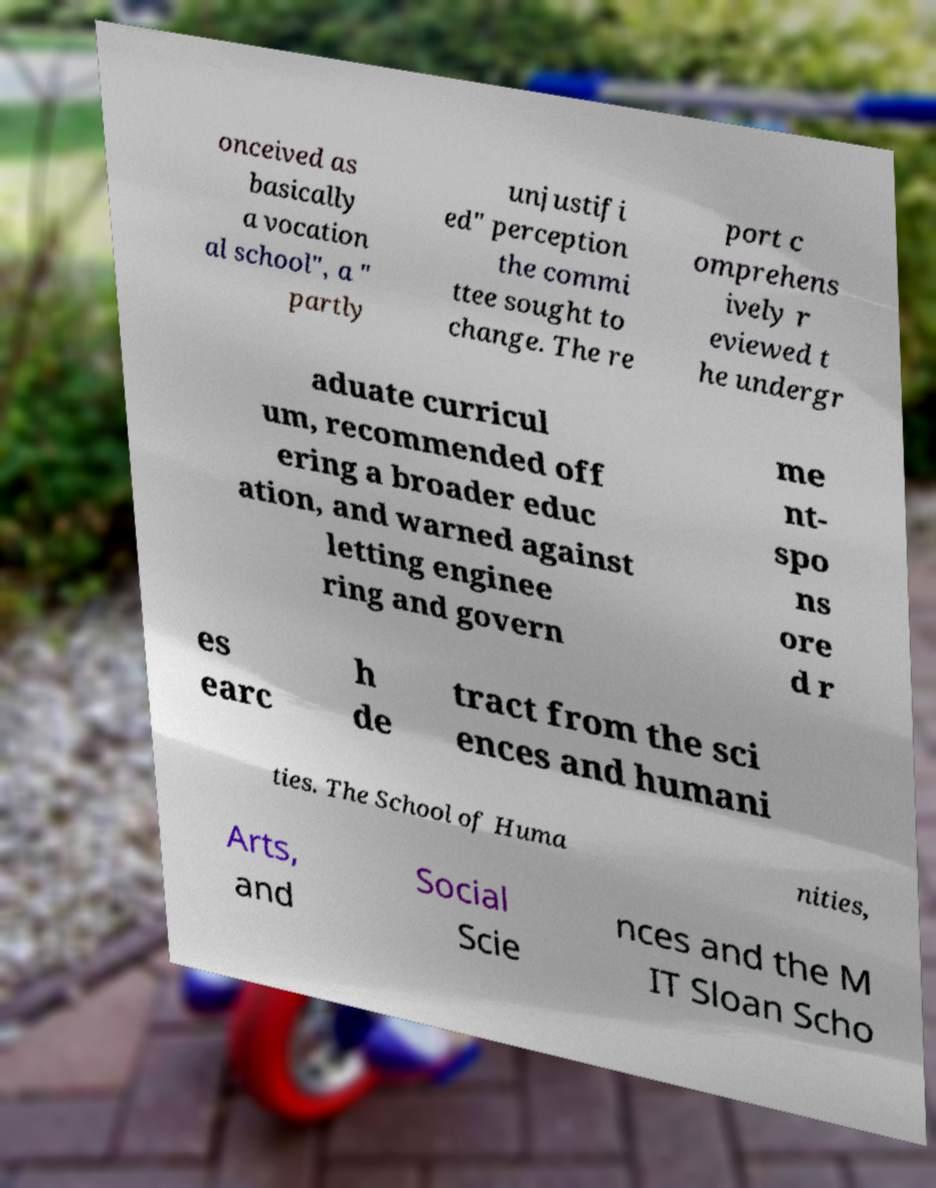Can you read and provide the text displayed in the image?This photo seems to have some interesting text. Can you extract and type it out for me? onceived as basically a vocation al school", a " partly unjustifi ed" perception the commi ttee sought to change. The re port c omprehens ively r eviewed t he undergr aduate curricul um, recommended off ering a broader educ ation, and warned against letting enginee ring and govern me nt- spo ns ore d r es earc h de tract from the sci ences and humani ties. The School of Huma nities, Arts, and Social Scie nces and the M IT Sloan Scho 